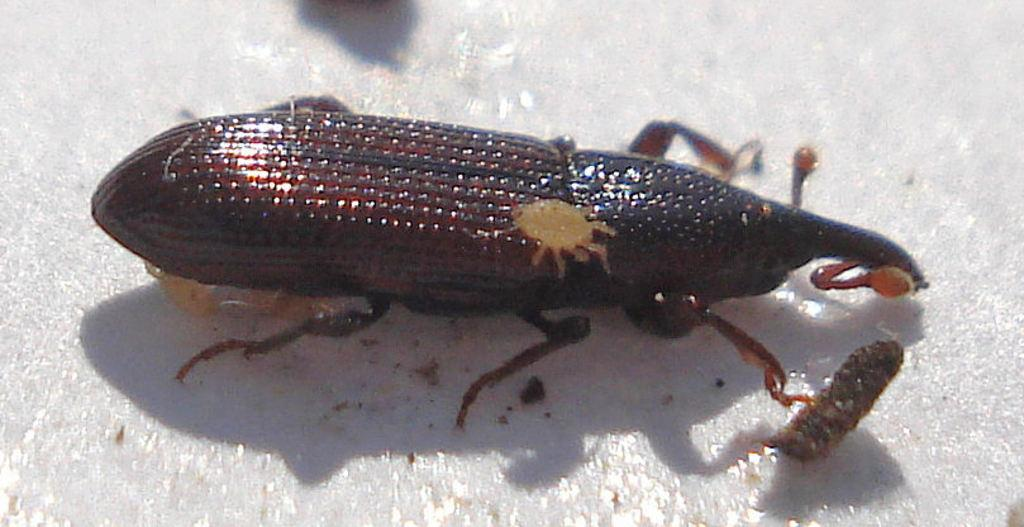What type of creature can be seen in the image? There is an insect in the image. Where is the insect located in the image? The insect is on the ground. What type of insurance is the insect using in the image? There is no mention of insurance in the image, as it features an insect on the ground. 